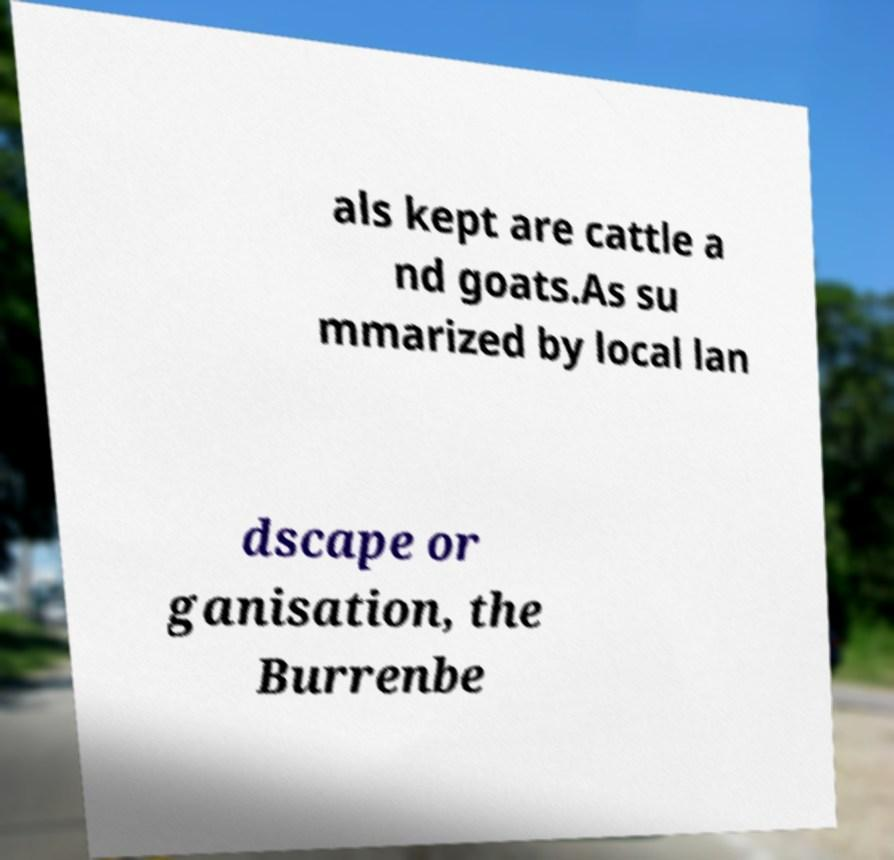Could you assist in decoding the text presented in this image and type it out clearly? als kept are cattle a nd goats.As su mmarized by local lan dscape or ganisation, the Burrenbe 